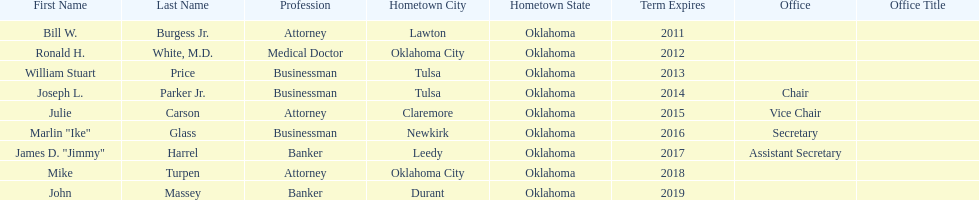Which state regent is from the same hometown as ronald h. white, m.d.? Mike Turpen. 